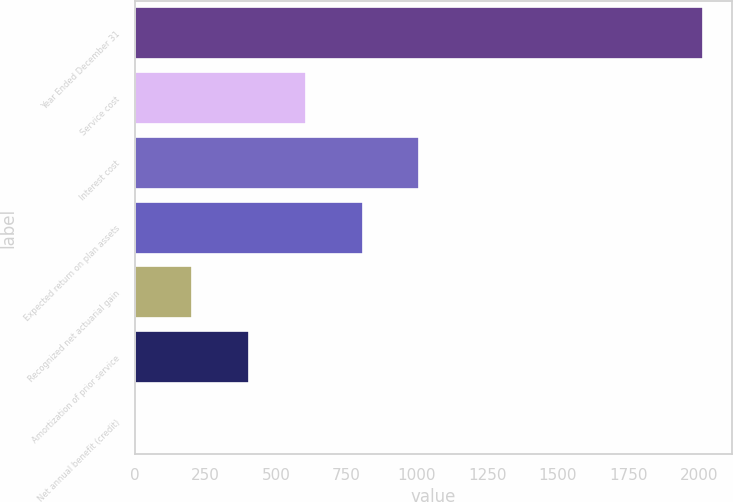Convert chart. <chart><loc_0><loc_0><loc_500><loc_500><bar_chart><fcel>Year Ended December 31<fcel>Service cost<fcel>Interest cost<fcel>Expected return on plan assets<fcel>Recognized net actuarial gain<fcel>Amortization of prior service<fcel>Net annual benefit (credit)<nl><fcel>2016<fcel>606.2<fcel>1009<fcel>807.6<fcel>203.4<fcel>404.8<fcel>2<nl></chart> 